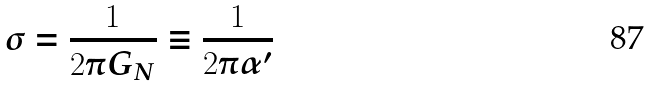Convert formula to latex. <formula><loc_0><loc_0><loc_500><loc_500>\sigma = \frac { 1 } { 2 \pi G _ { N } } \equiv \frac { 1 } { 2 \pi \alpha ^ { \prime } }</formula> 